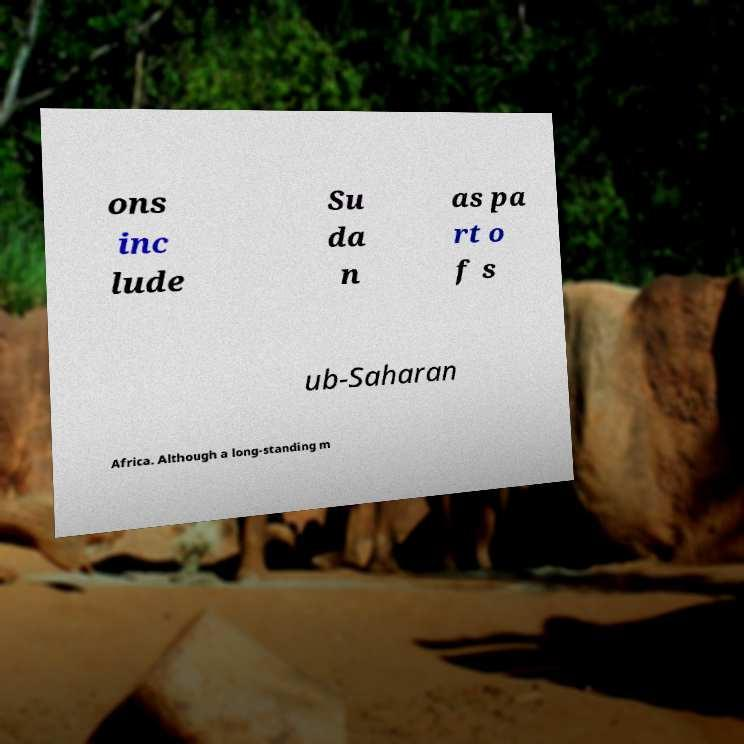Please read and relay the text visible in this image. What does it say? ons inc lude Su da n as pa rt o f s ub-Saharan Africa. Although a long-standing m 